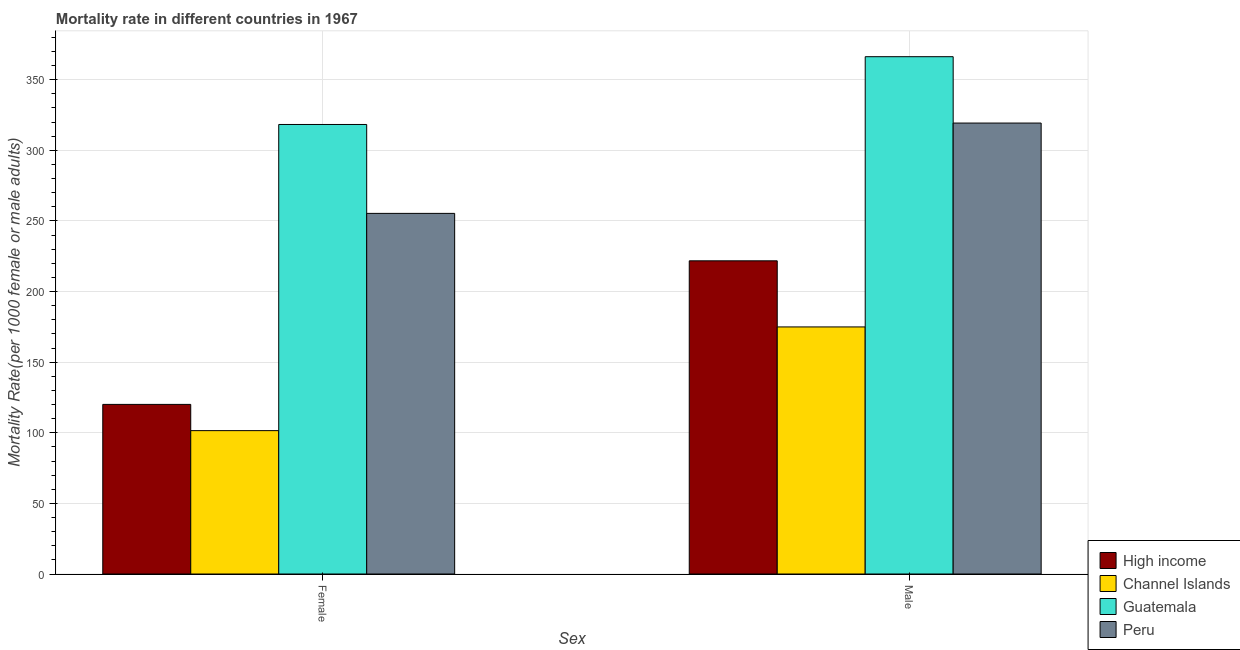How many different coloured bars are there?
Offer a terse response. 4. How many groups of bars are there?
Offer a terse response. 2. Are the number of bars per tick equal to the number of legend labels?
Your answer should be compact. Yes. Are the number of bars on each tick of the X-axis equal?
Provide a succinct answer. Yes. How many bars are there on the 1st tick from the left?
Your response must be concise. 4. What is the label of the 1st group of bars from the left?
Provide a succinct answer. Female. What is the female mortality rate in Channel Islands?
Ensure brevity in your answer.  101.5. Across all countries, what is the maximum female mortality rate?
Your answer should be compact. 318.26. Across all countries, what is the minimum female mortality rate?
Offer a terse response. 101.5. In which country was the male mortality rate maximum?
Give a very brief answer. Guatemala. In which country was the female mortality rate minimum?
Your answer should be compact. Channel Islands. What is the total female mortality rate in the graph?
Ensure brevity in your answer.  795.15. What is the difference between the male mortality rate in Peru and that in High income?
Your answer should be very brief. 97.54. What is the difference between the female mortality rate in High income and the male mortality rate in Channel Islands?
Your answer should be compact. -54.85. What is the average female mortality rate per country?
Offer a terse response. 198.79. What is the difference between the male mortality rate and female mortality rate in High income?
Your answer should be very brief. 101.65. What is the ratio of the female mortality rate in Channel Islands to that in Guatemala?
Your answer should be very brief. 0.32. Is the male mortality rate in Guatemala less than that in Channel Islands?
Provide a succinct answer. No. In how many countries, is the male mortality rate greater than the average male mortality rate taken over all countries?
Your answer should be very brief. 2. What does the 2nd bar from the right in Female represents?
Provide a succinct answer. Guatemala. How many bars are there?
Offer a terse response. 8. Are all the bars in the graph horizontal?
Your answer should be compact. No. How many countries are there in the graph?
Ensure brevity in your answer.  4. Where does the legend appear in the graph?
Give a very brief answer. Bottom right. How many legend labels are there?
Your answer should be very brief. 4. How are the legend labels stacked?
Offer a terse response. Vertical. What is the title of the graph?
Offer a terse response. Mortality rate in different countries in 1967. Does "Australia" appear as one of the legend labels in the graph?
Your answer should be very brief. No. What is the label or title of the X-axis?
Provide a succinct answer. Sex. What is the label or title of the Y-axis?
Offer a terse response. Mortality Rate(per 1000 female or male adults). What is the Mortality Rate(per 1000 female or male adults) in High income in Female?
Give a very brief answer. 120.08. What is the Mortality Rate(per 1000 female or male adults) in Channel Islands in Female?
Provide a short and direct response. 101.5. What is the Mortality Rate(per 1000 female or male adults) of Guatemala in Female?
Offer a terse response. 318.26. What is the Mortality Rate(per 1000 female or male adults) in Peru in Female?
Make the answer very short. 255.31. What is the Mortality Rate(per 1000 female or male adults) in High income in Male?
Offer a terse response. 221.73. What is the Mortality Rate(per 1000 female or male adults) of Channel Islands in Male?
Your answer should be compact. 174.93. What is the Mortality Rate(per 1000 female or male adults) in Guatemala in Male?
Offer a terse response. 366.25. What is the Mortality Rate(per 1000 female or male adults) in Peru in Male?
Ensure brevity in your answer.  319.27. Across all Sex, what is the maximum Mortality Rate(per 1000 female or male adults) of High income?
Provide a succinct answer. 221.73. Across all Sex, what is the maximum Mortality Rate(per 1000 female or male adults) of Channel Islands?
Provide a succinct answer. 174.93. Across all Sex, what is the maximum Mortality Rate(per 1000 female or male adults) of Guatemala?
Your response must be concise. 366.25. Across all Sex, what is the maximum Mortality Rate(per 1000 female or male adults) of Peru?
Offer a very short reply. 319.27. Across all Sex, what is the minimum Mortality Rate(per 1000 female or male adults) of High income?
Provide a short and direct response. 120.08. Across all Sex, what is the minimum Mortality Rate(per 1000 female or male adults) in Channel Islands?
Your answer should be compact. 101.5. Across all Sex, what is the minimum Mortality Rate(per 1000 female or male adults) in Guatemala?
Your answer should be very brief. 318.26. Across all Sex, what is the minimum Mortality Rate(per 1000 female or male adults) of Peru?
Your answer should be compact. 255.31. What is the total Mortality Rate(per 1000 female or male adults) in High income in the graph?
Keep it short and to the point. 341.8. What is the total Mortality Rate(per 1000 female or male adults) of Channel Islands in the graph?
Keep it short and to the point. 276.43. What is the total Mortality Rate(per 1000 female or male adults) of Guatemala in the graph?
Make the answer very short. 684.51. What is the total Mortality Rate(per 1000 female or male adults) of Peru in the graph?
Offer a very short reply. 574.58. What is the difference between the Mortality Rate(per 1000 female or male adults) in High income in Female and that in Male?
Provide a succinct answer. -101.65. What is the difference between the Mortality Rate(per 1000 female or male adults) of Channel Islands in Female and that in Male?
Offer a very short reply. -73.42. What is the difference between the Mortality Rate(per 1000 female or male adults) in Guatemala in Female and that in Male?
Provide a short and direct response. -47.99. What is the difference between the Mortality Rate(per 1000 female or male adults) in Peru in Female and that in Male?
Give a very brief answer. -63.96. What is the difference between the Mortality Rate(per 1000 female or male adults) in High income in Female and the Mortality Rate(per 1000 female or male adults) in Channel Islands in Male?
Your response must be concise. -54.85. What is the difference between the Mortality Rate(per 1000 female or male adults) in High income in Female and the Mortality Rate(per 1000 female or male adults) in Guatemala in Male?
Your answer should be very brief. -246.17. What is the difference between the Mortality Rate(per 1000 female or male adults) in High income in Female and the Mortality Rate(per 1000 female or male adults) in Peru in Male?
Offer a very short reply. -199.19. What is the difference between the Mortality Rate(per 1000 female or male adults) in Channel Islands in Female and the Mortality Rate(per 1000 female or male adults) in Guatemala in Male?
Your answer should be compact. -264.75. What is the difference between the Mortality Rate(per 1000 female or male adults) in Channel Islands in Female and the Mortality Rate(per 1000 female or male adults) in Peru in Male?
Your answer should be compact. -217.77. What is the difference between the Mortality Rate(per 1000 female or male adults) in Guatemala in Female and the Mortality Rate(per 1000 female or male adults) in Peru in Male?
Your answer should be compact. -1.01. What is the average Mortality Rate(per 1000 female or male adults) of High income per Sex?
Give a very brief answer. 170.9. What is the average Mortality Rate(per 1000 female or male adults) in Channel Islands per Sex?
Provide a short and direct response. 138.21. What is the average Mortality Rate(per 1000 female or male adults) of Guatemala per Sex?
Ensure brevity in your answer.  342.25. What is the average Mortality Rate(per 1000 female or male adults) in Peru per Sex?
Make the answer very short. 287.29. What is the difference between the Mortality Rate(per 1000 female or male adults) in High income and Mortality Rate(per 1000 female or male adults) in Channel Islands in Female?
Provide a succinct answer. 18.58. What is the difference between the Mortality Rate(per 1000 female or male adults) of High income and Mortality Rate(per 1000 female or male adults) of Guatemala in Female?
Provide a short and direct response. -198.18. What is the difference between the Mortality Rate(per 1000 female or male adults) of High income and Mortality Rate(per 1000 female or male adults) of Peru in Female?
Provide a succinct answer. -135.24. What is the difference between the Mortality Rate(per 1000 female or male adults) in Channel Islands and Mortality Rate(per 1000 female or male adults) in Guatemala in Female?
Your answer should be compact. -216.76. What is the difference between the Mortality Rate(per 1000 female or male adults) in Channel Islands and Mortality Rate(per 1000 female or male adults) in Peru in Female?
Your response must be concise. -153.81. What is the difference between the Mortality Rate(per 1000 female or male adults) in Guatemala and Mortality Rate(per 1000 female or male adults) in Peru in Female?
Keep it short and to the point. 62.95. What is the difference between the Mortality Rate(per 1000 female or male adults) in High income and Mortality Rate(per 1000 female or male adults) in Channel Islands in Male?
Provide a short and direct response. 46.8. What is the difference between the Mortality Rate(per 1000 female or male adults) in High income and Mortality Rate(per 1000 female or male adults) in Guatemala in Male?
Provide a succinct answer. -144.52. What is the difference between the Mortality Rate(per 1000 female or male adults) of High income and Mortality Rate(per 1000 female or male adults) of Peru in Male?
Your answer should be compact. -97.54. What is the difference between the Mortality Rate(per 1000 female or male adults) in Channel Islands and Mortality Rate(per 1000 female or male adults) in Guatemala in Male?
Keep it short and to the point. -191.32. What is the difference between the Mortality Rate(per 1000 female or male adults) of Channel Islands and Mortality Rate(per 1000 female or male adults) of Peru in Male?
Offer a very short reply. -144.34. What is the difference between the Mortality Rate(per 1000 female or male adults) of Guatemala and Mortality Rate(per 1000 female or male adults) of Peru in Male?
Your response must be concise. 46.98. What is the ratio of the Mortality Rate(per 1000 female or male adults) in High income in Female to that in Male?
Your answer should be compact. 0.54. What is the ratio of the Mortality Rate(per 1000 female or male adults) of Channel Islands in Female to that in Male?
Give a very brief answer. 0.58. What is the ratio of the Mortality Rate(per 1000 female or male adults) of Guatemala in Female to that in Male?
Your answer should be very brief. 0.87. What is the ratio of the Mortality Rate(per 1000 female or male adults) of Peru in Female to that in Male?
Keep it short and to the point. 0.8. What is the difference between the highest and the second highest Mortality Rate(per 1000 female or male adults) of High income?
Provide a succinct answer. 101.65. What is the difference between the highest and the second highest Mortality Rate(per 1000 female or male adults) in Channel Islands?
Offer a very short reply. 73.42. What is the difference between the highest and the second highest Mortality Rate(per 1000 female or male adults) in Guatemala?
Provide a succinct answer. 47.99. What is the difference between the highest and the second highest Mortality Rate(per 1000 female or male adults) in Peru?
Provide a succinct answer. 63.96. What is the difference between the highest and the lowest Mortality Rate(per 1000 female or male adults) in High income?
Your answer should be very brief. 101.65. What is the difference between the highest and the lowest Mortality Rate(per 1000 female or male adults) in Channel Islands?
Keep it short and to the point. 73.42. What is the difference between the highest and the lowest Mortality Rate(per 1000 female or male adults) in Guatemala?
Give a very brief answer. 47.99. What is the difference between the highest and the lowest Mortality Rate(per 1000 female or male adults) in Peru?
Provide a succinct answer. 63.96. 